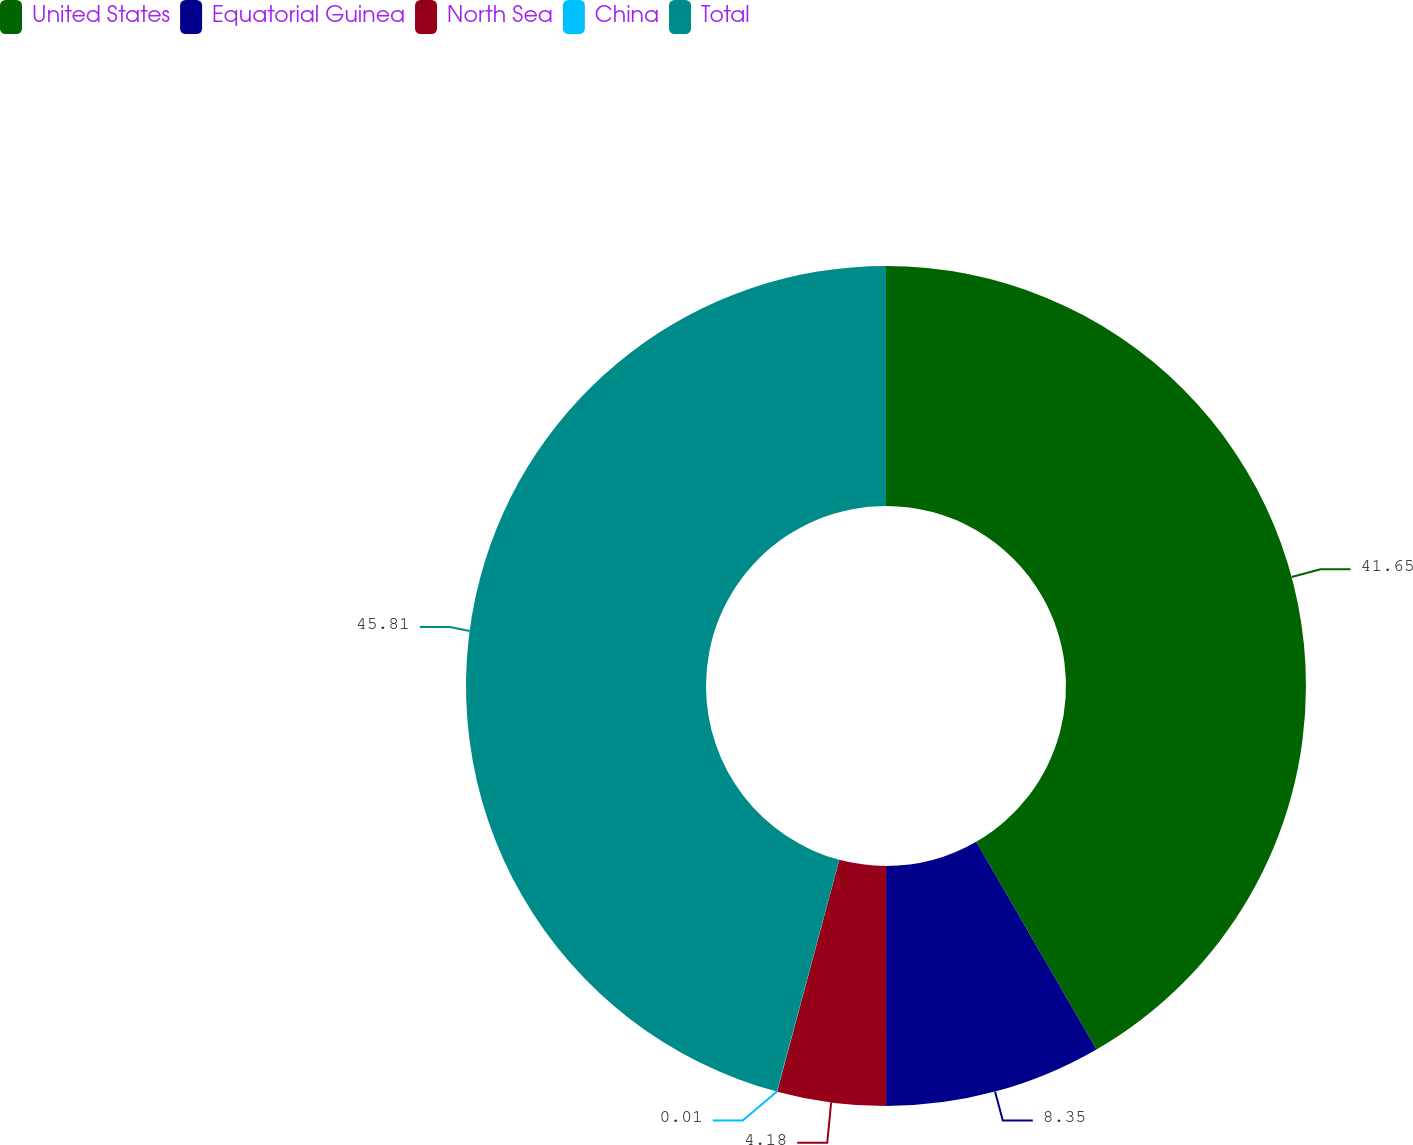<chart> <loc_0><loc_0><loc_500><loc_500><pie_chart><fcel>United States<fcel>Equatorial Guinea<fcel>North Sea<fcel>China<fcel>Total<nl><fcel>41.65%<fcel>8.35%<fcel>4.18%<fcel>0.01%<fcel>45.82%<nl></chart> 